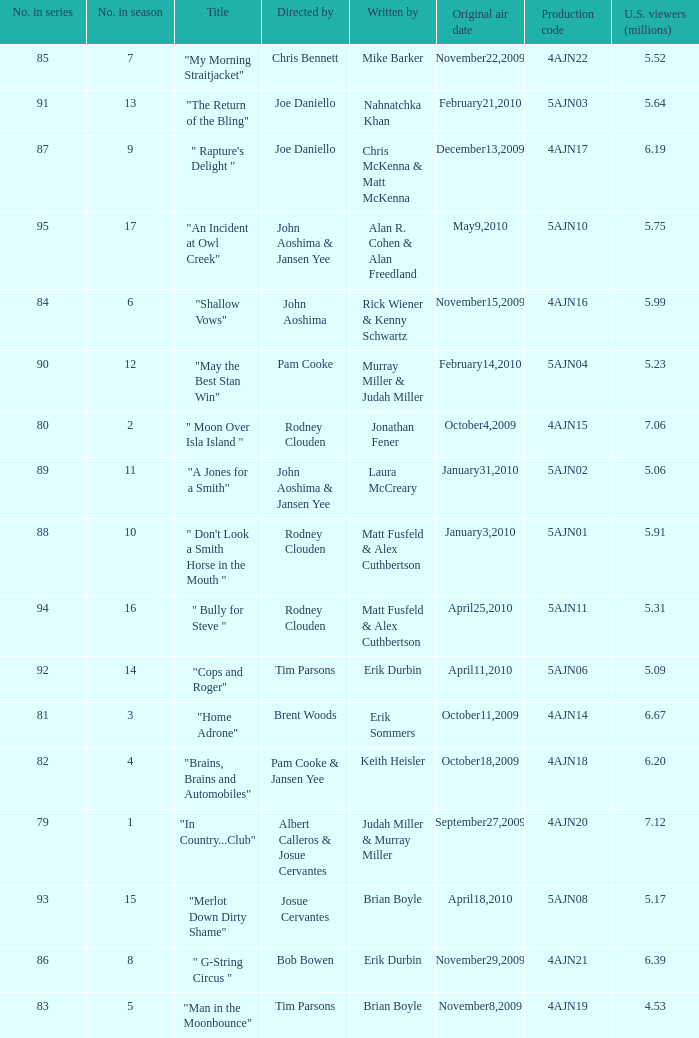Who is the writer of the episode directed by pam cooke & jansen yee? Keith Heisler. 